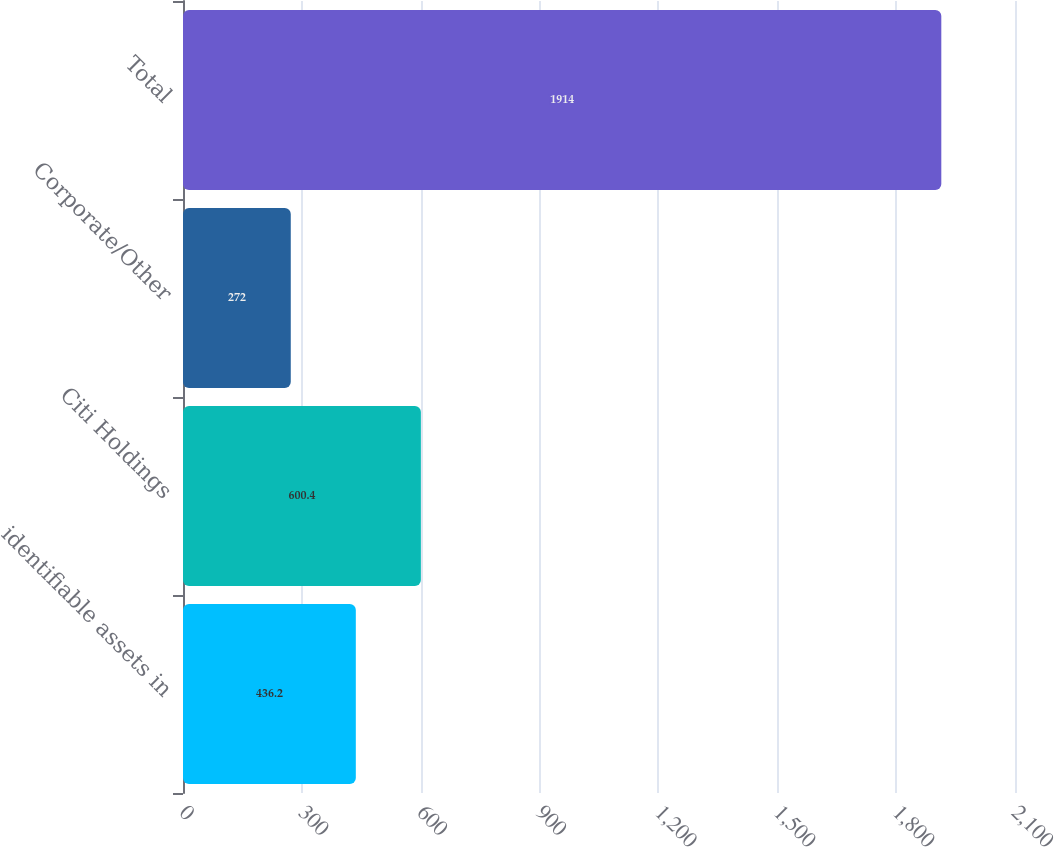<chart> <loc_0><loc_0><loc_500><loc_500><bar_chart><fcel>identifiable assets in<fcel>Citi Holdings<fcel>Corporate/Other<fcel>Total<nl><fcel>436.2<fcel>600.4<fcel>272<fcel>1914<nl></chart> 